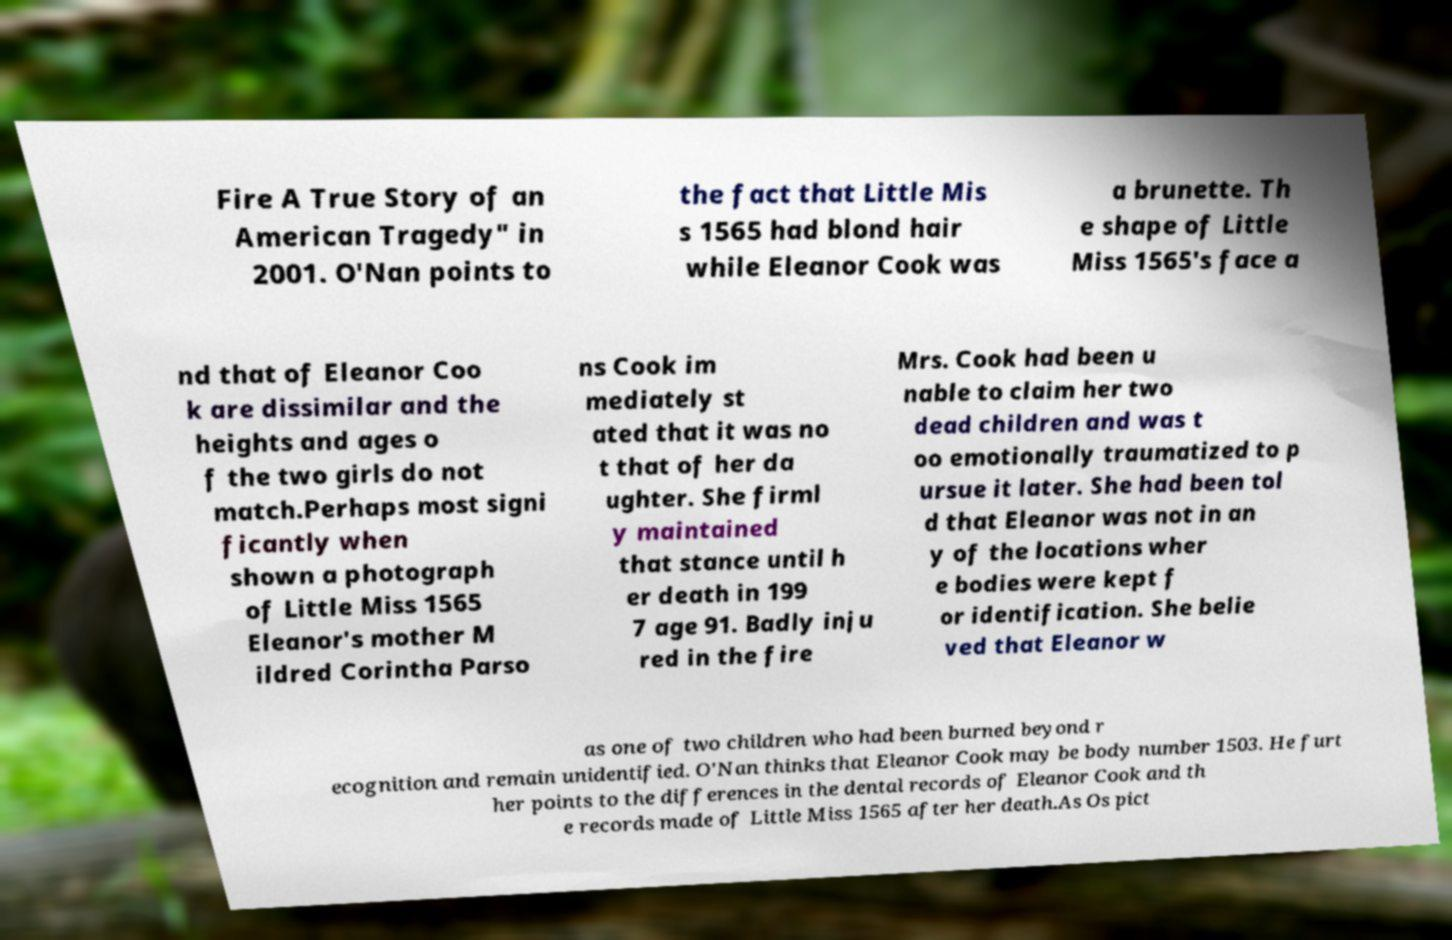There's text embedded in this image that I need extracted. Can you transcribe it verbatim? Fire A True Story of an American Tragedy" in 2001. O'Nan points to the fact that Little Mis s 1565 had blond hair while Eleanor Cook was a brunette. Th e shape of Little Miss 1565's face a nd that of Eleanor Coo k are dissimilar and the heights and ages o f the two girls do not match.Perhaps most signi ficantly when shown a photograph of Little Miss 1565 Eleanor's mother M ildred Corintha Parso ns Cook im mediately st ated that it was no t that of her da ughter. She firml y maintained that stance until h er death in 199 7 age 91. Badly inju red in the fire Mrs. Cook had been u nable to claim her two dead children and was t oo emotionally traumatized to p ursue it later. She had been tol d that Eleanor was not in an y of the locations wher e bodies were kept f or identification. She belie ved that Eleanor w as one of two children who had been burned beyond r ecognition and remain unidentified. O'Nan thinks that Eleanor Cook may be body number 1503. He furt her points to the differences in the dental records of Eleanor Cook and th e records made of Little Miss 1565 after her death.As Os pict 